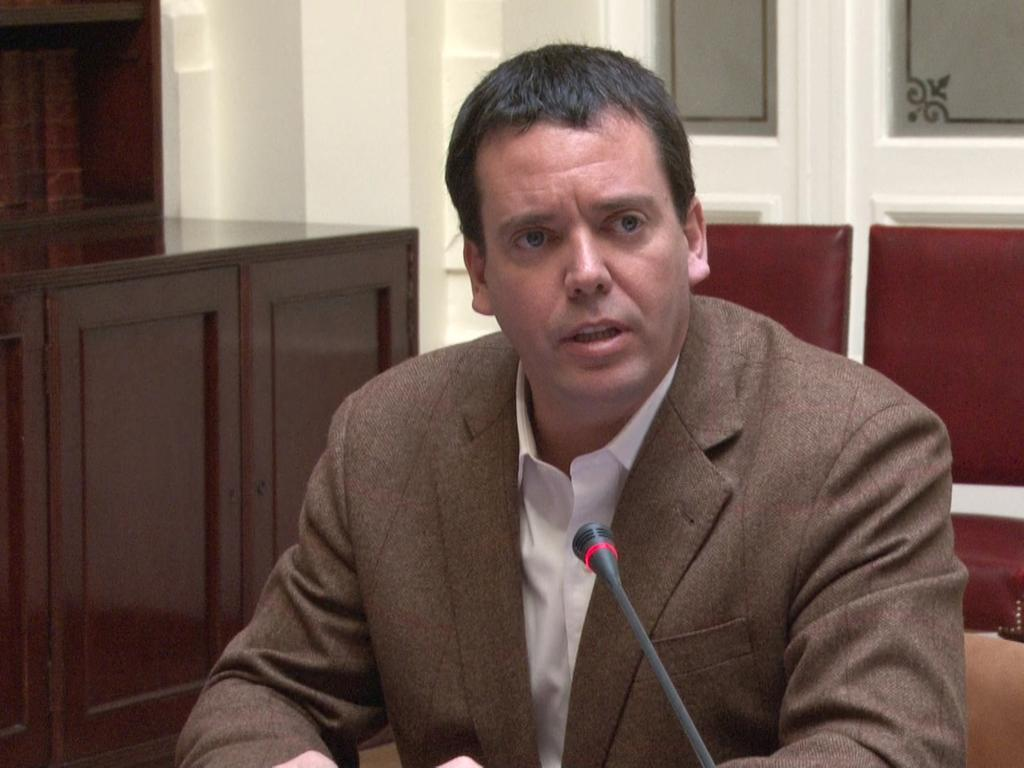Who is present in the image? There is a man in the image. What object is the man holding in the image? There is a microphone in the image. What can be seen in the background of the image? There are cupboards, a wall, and chairs in the background of the image. What is the price of the form that the sun is holding in the image? There is no form or sun present in the image. 